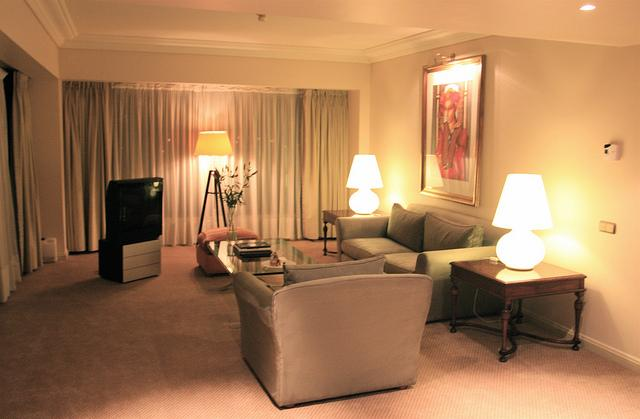What is the large black object used for?

Choices:
A) watching television
B) eating
C) cooking
D) storage watching television 